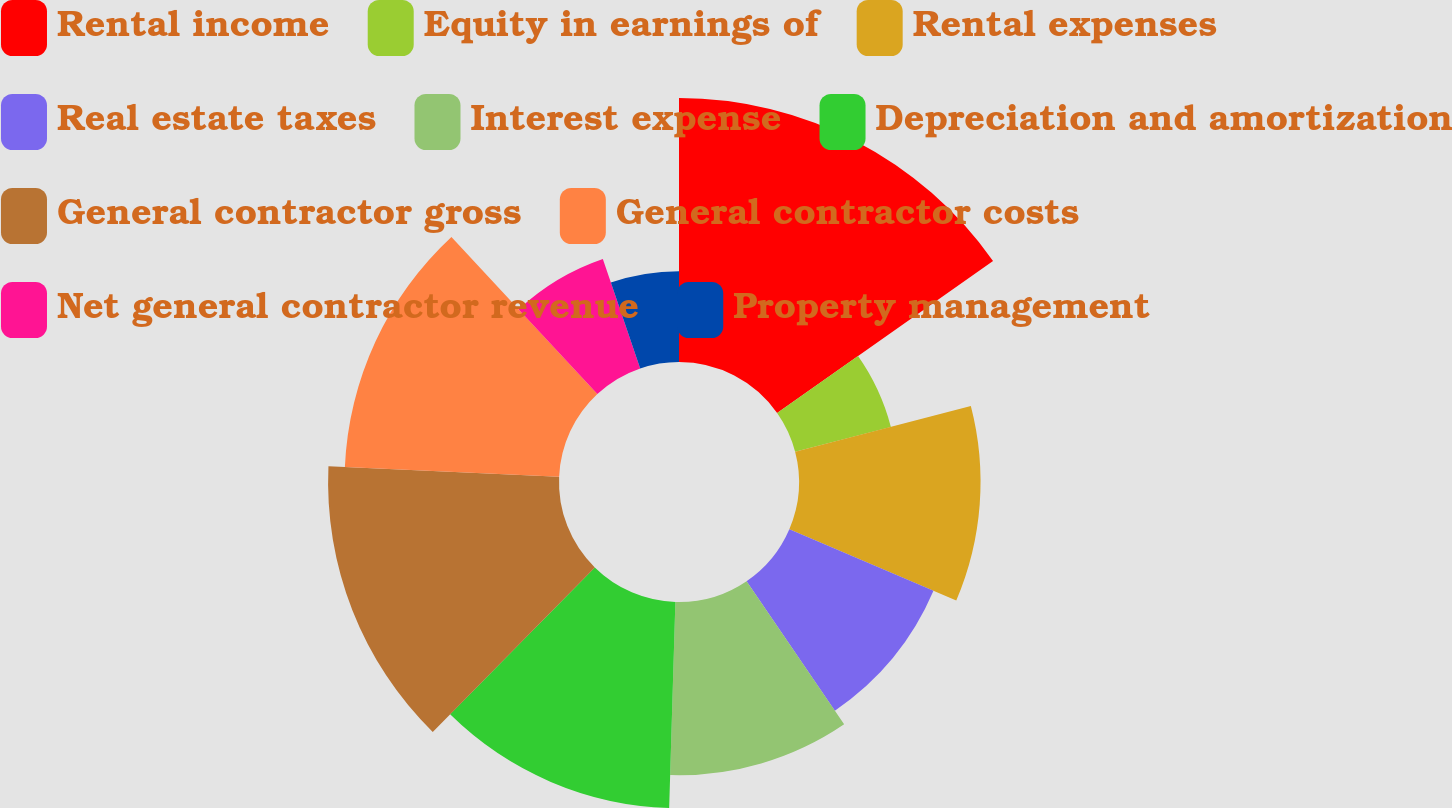Convert chart. <chart><loc_0><loc_0><loc_500><loc_500><pie_chart><fcel>Rental income<fcel>Equity in earnings of<fcel>Rental expenses<fcel>Real estate taxes<fcel>Interest expense<fcel>Depreciation and amortization<fcel>General contractor gross<fcel>General contractor costs<fcel>Net general contractor revenue<fcel>Property management<nl><fcel>15.24%<fcel>5.71%<fcel>10.48%<fcel>9.05%<fcel>10.0%<fcel>11.9%<fcel>13.33%<fcel>12.38%<fcel>6.67%<fcel>5.24%<nl></chart> 